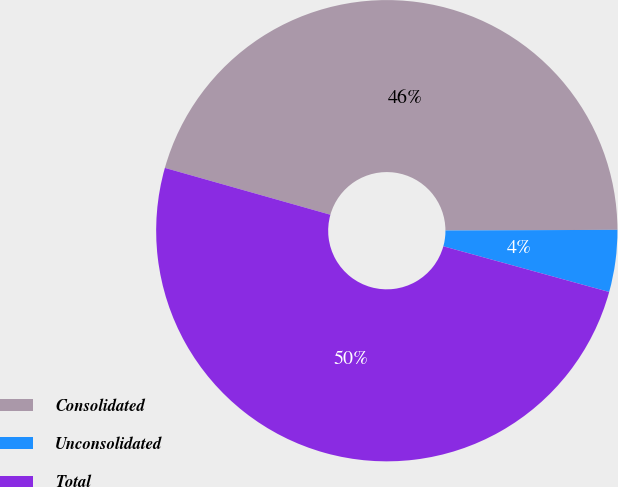Convert chart. <chart><loc_0><loc_0><loc_500><loc_500><pie_chart><fcel>Consolidated<fcel>Unconsolidated<fcel>Total<nl><fcel>45.55%<fcel>4.34%<fcel>50.11%<nl></chart> 